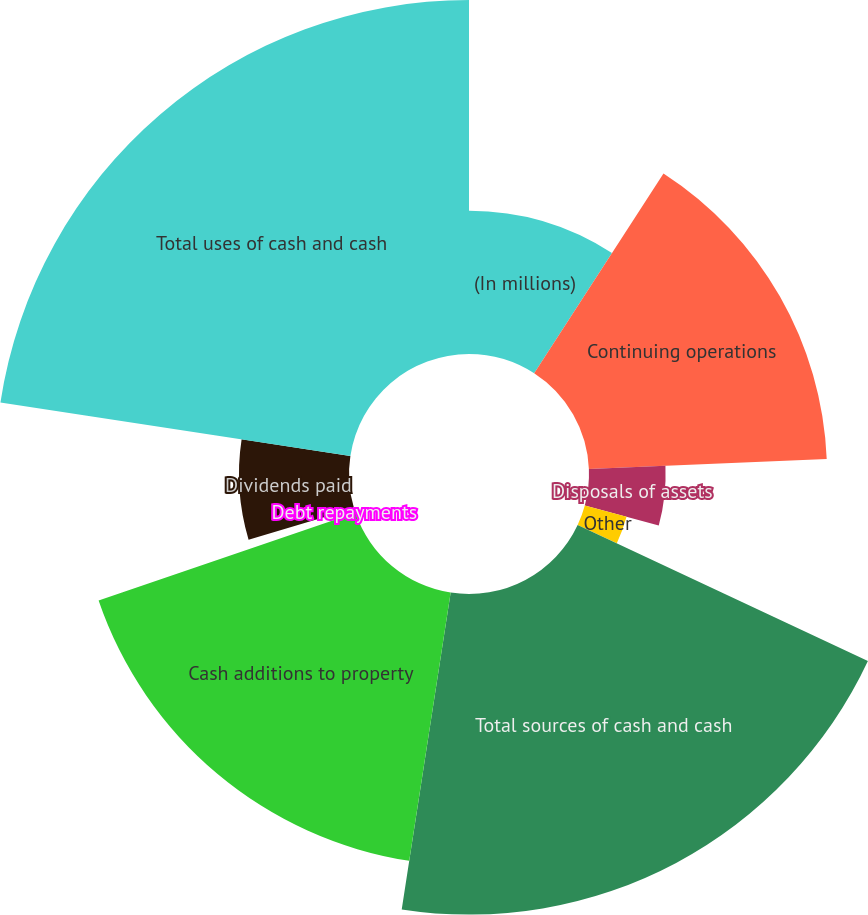Convert chart. <chart><loc_0><loc_0><loc_500><loc_500><pie_chart><fcel>(In millions)<fcel>Continuing operations<fcel>Disposals of assets<fcel>Other<fcel>Total sources of cash and cash<fcel>Cash additions to property<fcel>Debt repayments<fcel>Dividends paid<fcel>Total uses of cash and cash<nl><fcel>9.14%<fcel>15.19%<fcel>4.89%<fcel>2.76%<fcel>20.46%<fcel>17.32%<fcel>0.63%<fcel>7.02%<fcel>22.59%<nl></chart> 